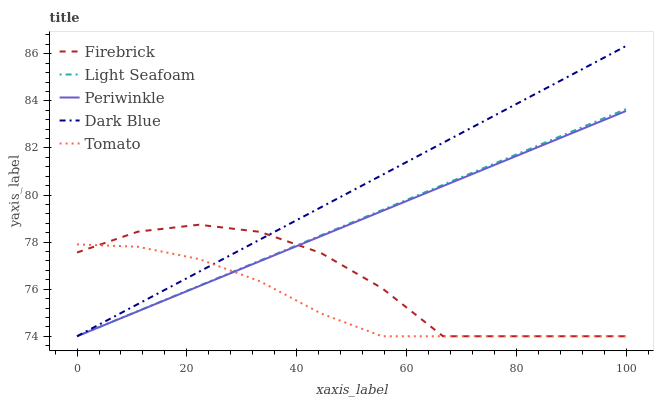Does Tomato have the minimum area under the curve?
Answer yes or no. Yes. Does Dark Blue have the maximum area under the curve?
Answer yes or no. Yes. Does Firebrick have the minimum area under the curve?
Answer yes or no. No. Does Firebrick have the maximum area under the curve?
Answer yes or no. No. Is Dark Blue the smoothest?
Answer yes or no. Yes. Is Firebrick the roughest?
Answer yes or no. Yes. Is Firebrick the smoothest?
Answer yes or no. No. Is Dark Blue the roughest?
Answer yes or no. No. Does Tomato have the lowest value?
Answer yes or no. Yes. Does Dark Blue have the highest value?
Answer yes or no. Yes. Does Firebrick have the highest value?
Answer yes or no. No. Does Light Seafoam intersect Periwinkle?
Answer yes or no. Yes. Is Light Seafoam less than Periwinkle?
Answer yes or no. No. Is Light Seafoam greater than Periwinkle?
Answer yes or no. No. 